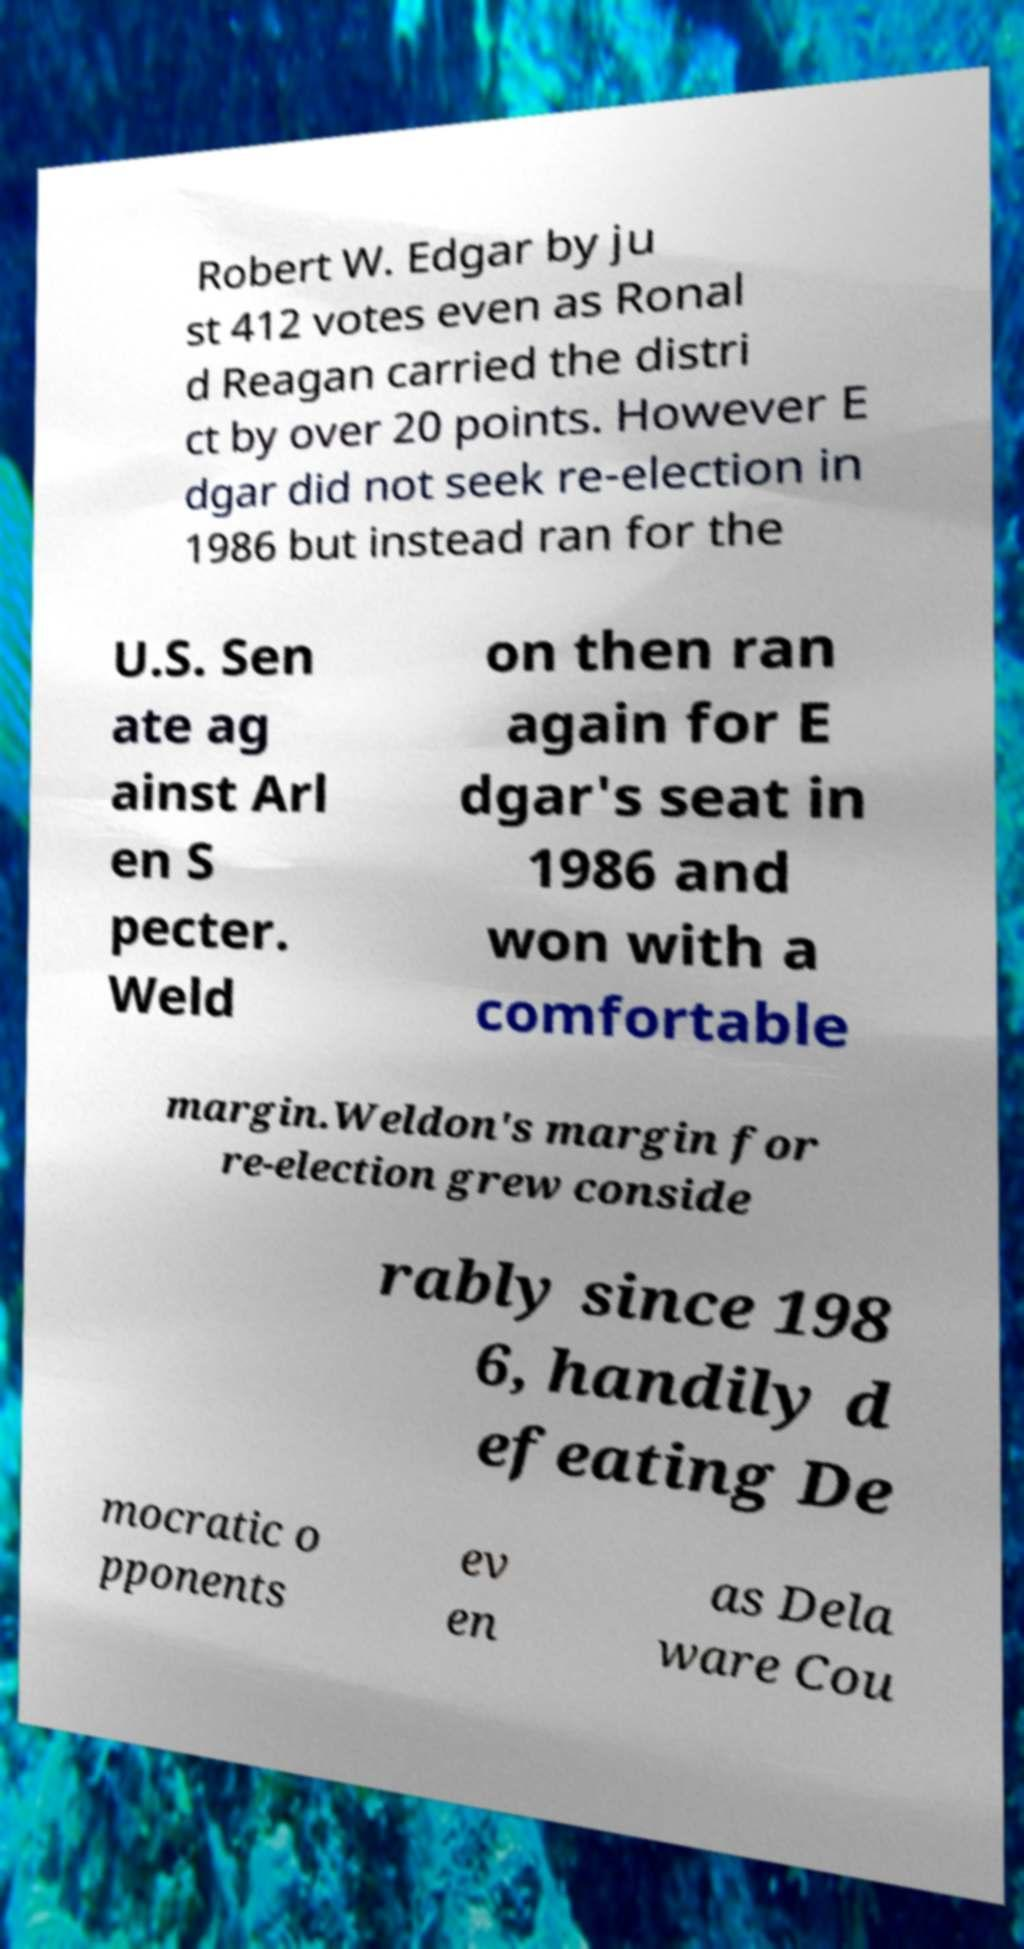Could you assist in decoding the text presented in this image and type it out clearly? Robert W. Edgar by ju st 412 votes even as Ronal d Reagan carried the distri ct by over 20 points. However E dgar did not seek re-election in 1986 but instead ran for the U.S. Sen ate ag ainst Arl en S pecter. Weld on then ran again for E dgar's seat in 1986 and won with a comfortable margin.Weldon's margin for re-election grew conside rably since 198 6, handily d efeating De mocratic o pponents ev en as Dela ware Cou 